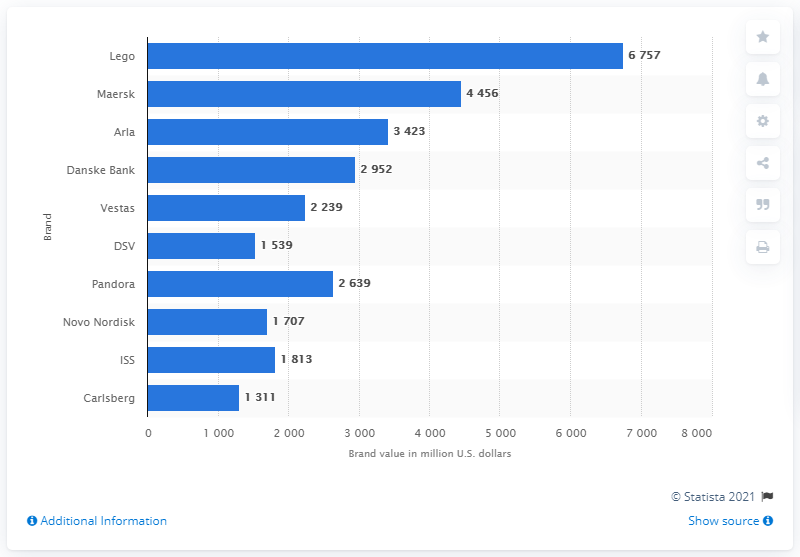Draw attention to some important aspects in this diagram. Lego was the leading Danish brand in terms of brand value in 2020. As of 2020, Lego's brand value in the United States was approximately 6,757 US dollars. 